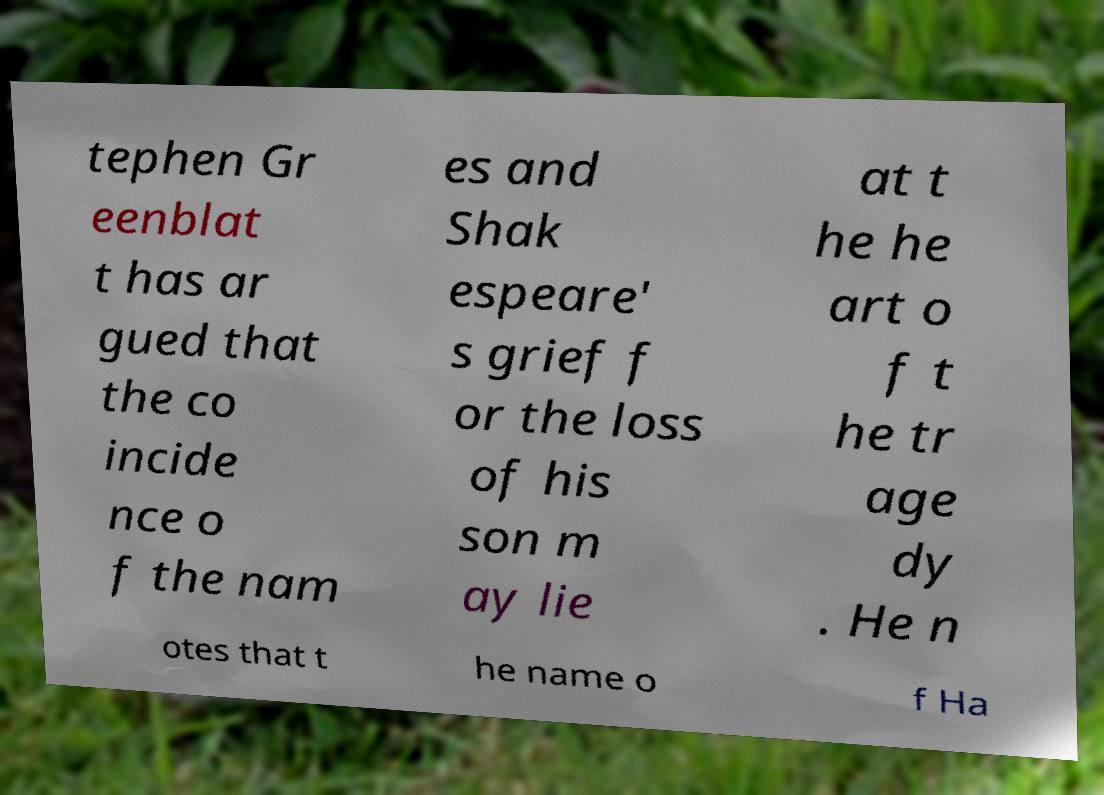Please read and relay the text visible in this image. What does it say? tephen Gr eenblat t has ar gued that the co incide nce o f the nam es and Shak espeare' s grief f or the loss of his son m ay lie at t he he art o f t he tr age dy . He n otes that t he name o f Ha 